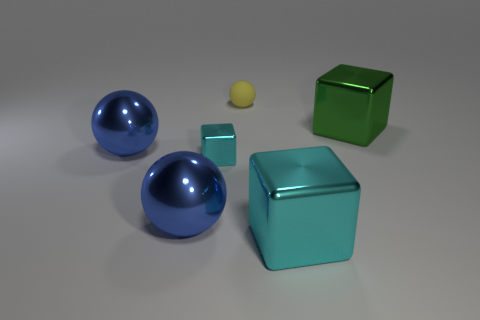Add 3 large yellow cylinders. How many objects exist? 9 Add 3 gray rubber cylinders. How many gray rubber cylinders exist? 3 Subtract 0 yellow cylinders. How many objects are left? 6 Subtract all cyan metallic spheres. Subtract all metal things. How many objects are left? 1 Add 5 tiny spheres. How many tiny spheres are left? 6 